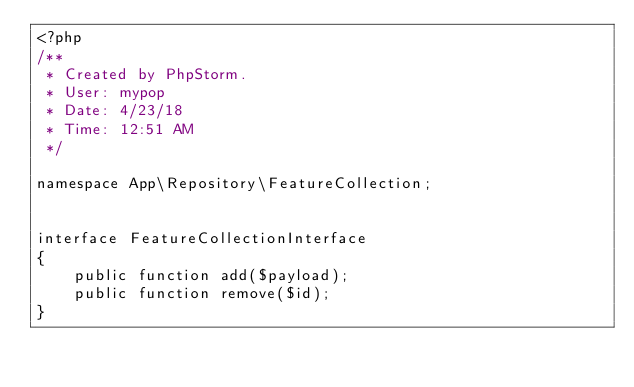<code> <loc_0><loc_0><loc_500><loc_500><_PHP_><?php
/**
 * Created by PhpStorm.
 * User: mypop
 * Date: 4/23/18
 * Time: 12:51 AM
 */

namespace App\Repository\FeatureCollection;


interface FeatureCollectionInterface
{
    public function add($payload);
    public function remove($id);
}</code> 